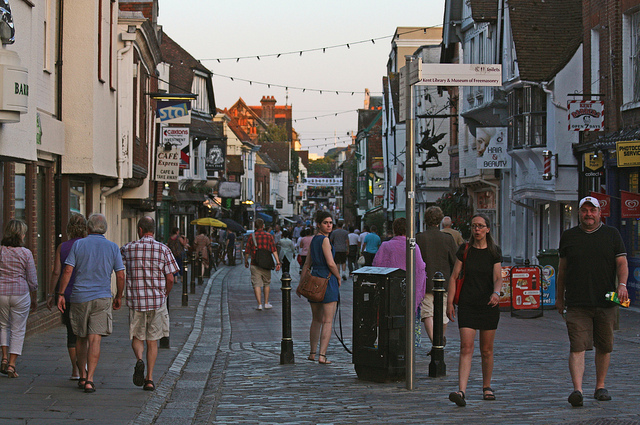What kind of area in town is this?
A. industrial
B. residential area
C. office buildings
D. shopping area The area shown in the image is a D. shopping area. This can be identified by the presence of multiple storefronts, signs advertising various businesses, a pedestrian-friendly street, and people casually browsing or walking through, likely engaging in shopping or leisure activities. The vibrant atmosphere and diverse range of shops suggest a locality designed for retail and commerce. 